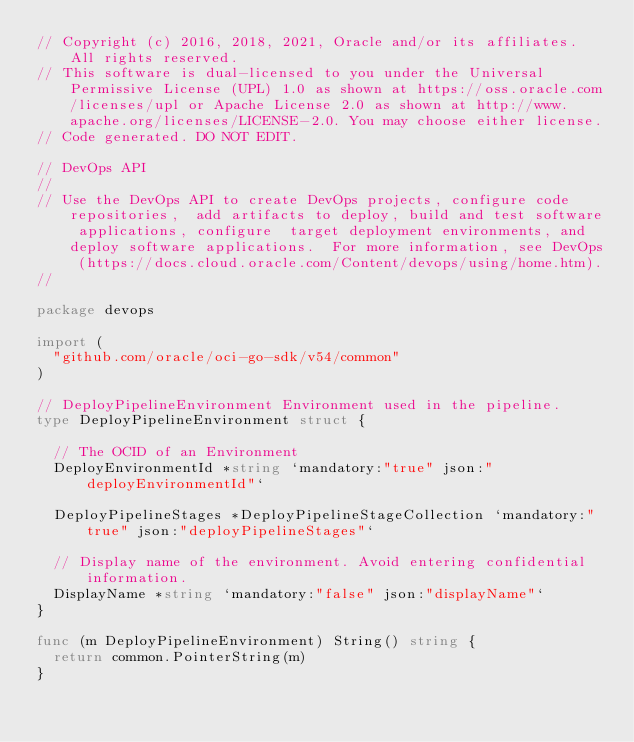Convert code to text. <code><loc_0><loc_0><loc_500><loc_500><_Go_>// Copyright (c) 2016, 2018, 2021, Oracle and/or its affiliates.  All rights reserved.
// This software is dual-licensed to you under the Universal Permissive License (UPL) 1.0 as shown at https://oss.oracle.com/licenses/upl or Apache License 2.0 as shown at http://www.apache.org/licenses/LICENSE-2.0. You may choose either license.
// Code generated. DO NOT EDIT.

// DevOps API
//
// Use the DevOps API to create DevOps projects, configure code repositories,  add artifacts to deploy, build and test software applications, configure  target deployment environments, and deploy software applications.  For more information, see DevOps (https://docs.cloud.oracle.com/Content/devops/using/home.htm).
//

package devops

import (
	"github.com/oracle/oci-go-sdk/v54/common"
)

// DeployPipelineEnvironment Environment used in the pipeline.
type DeployPipelineEnvironment struct {

	// The OCID of an Environment
	DeployEnvironmentId *string `mandatory:"true" json:"deployEnvironmentId"`

	DeployPipelineStages *DeployPipelineStageCollection `mandatory:"true" json:"deployPipelineStages"`

	// Display name of the environment. Avoid entering confidential information.
	DisplayName *string `mandatory:"false" json:"displayName"`
}

func (m DeployPipelineEnvironment) String() string {
	return common.PointerString(m)
}
</code> 